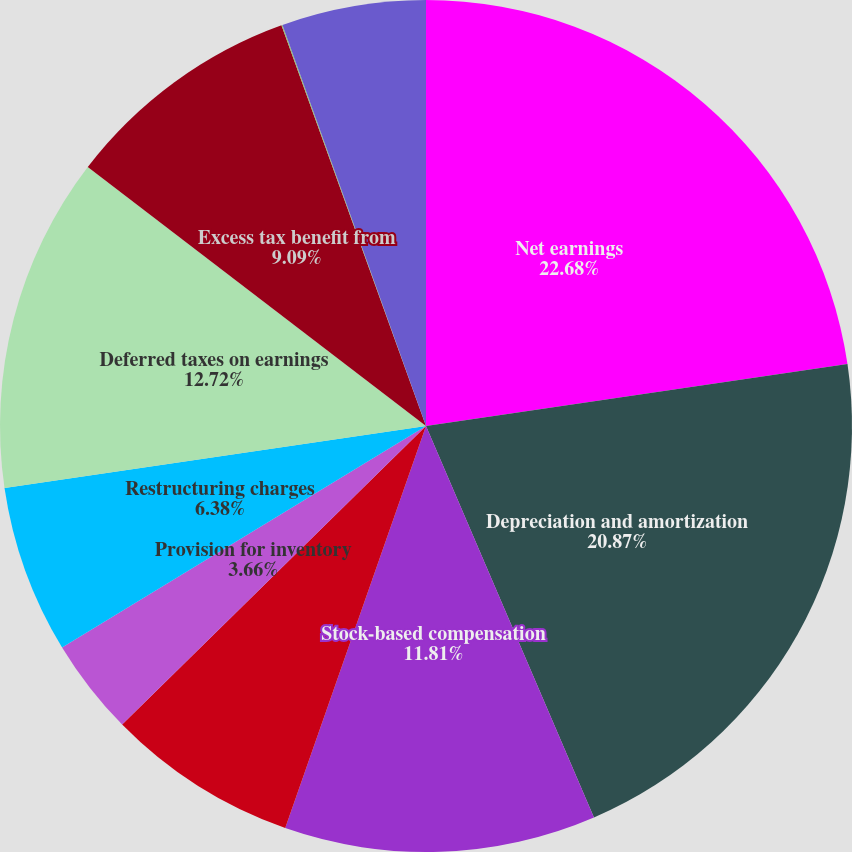Convert chart to OTSL. <chart><loc_0><loc_0><loc_500><loc_500><pie_chart><fcel>Net earnings<fcel>Depreciation and amortization<fcel>Stock-based compensation<fcel>Provision for doubtful<fcel>Provision for inventory<fcel>Restructuring charges<fcel>Deferred taxes on earnings<fcel>Excess tax benefit from<fcel>Other net<fcel>Accounts and financing<nl><fcel>22.68%<fcel>20.87%<fcel>11.81%<fcel>7.28%<fcel>3.66%<fcel>6.38%<fcel>12.72%<fcel>9.09%<fcel>0.04%<fcel>5.47%<nl></chart> 